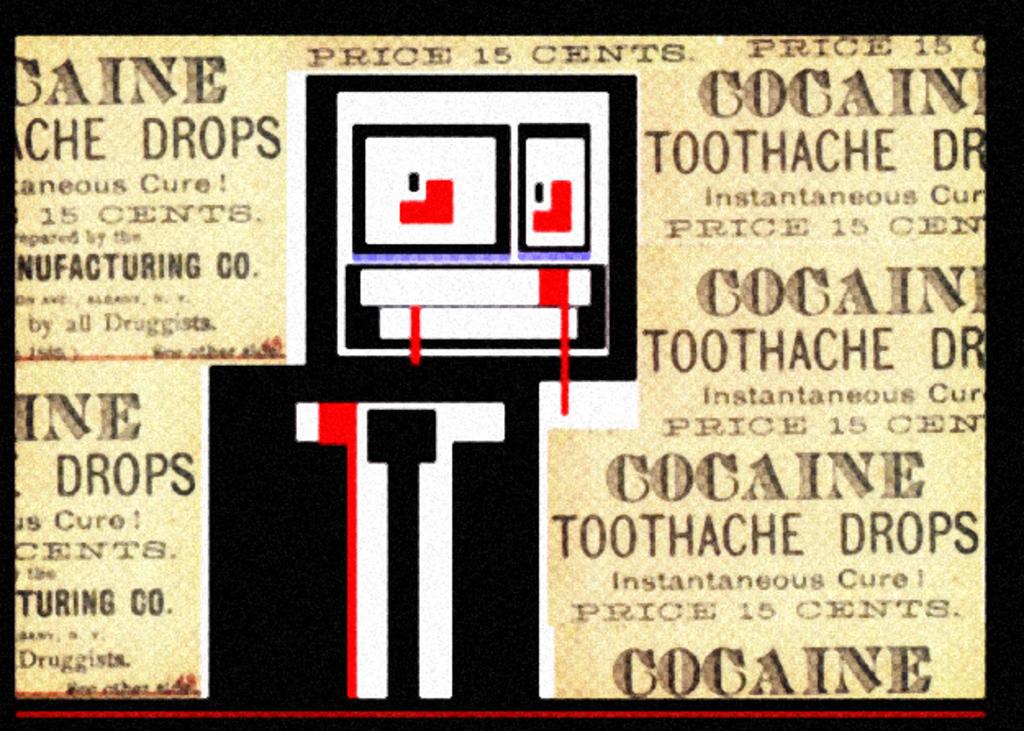Does cocaine help with pain?
Your answer should be very brief. Yes. Was cocaine created originally to deal with pain?
Offer a very short reply. Yes. 